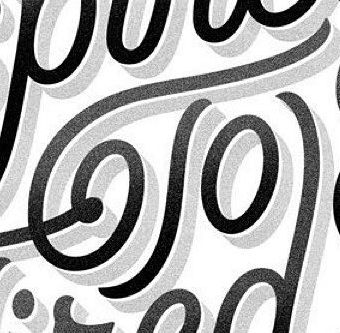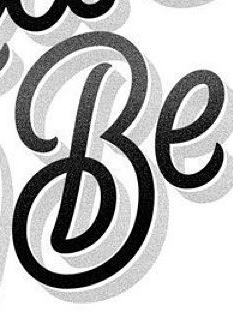What text appears in these images from left to right, separated by a semicolon? To; Be 